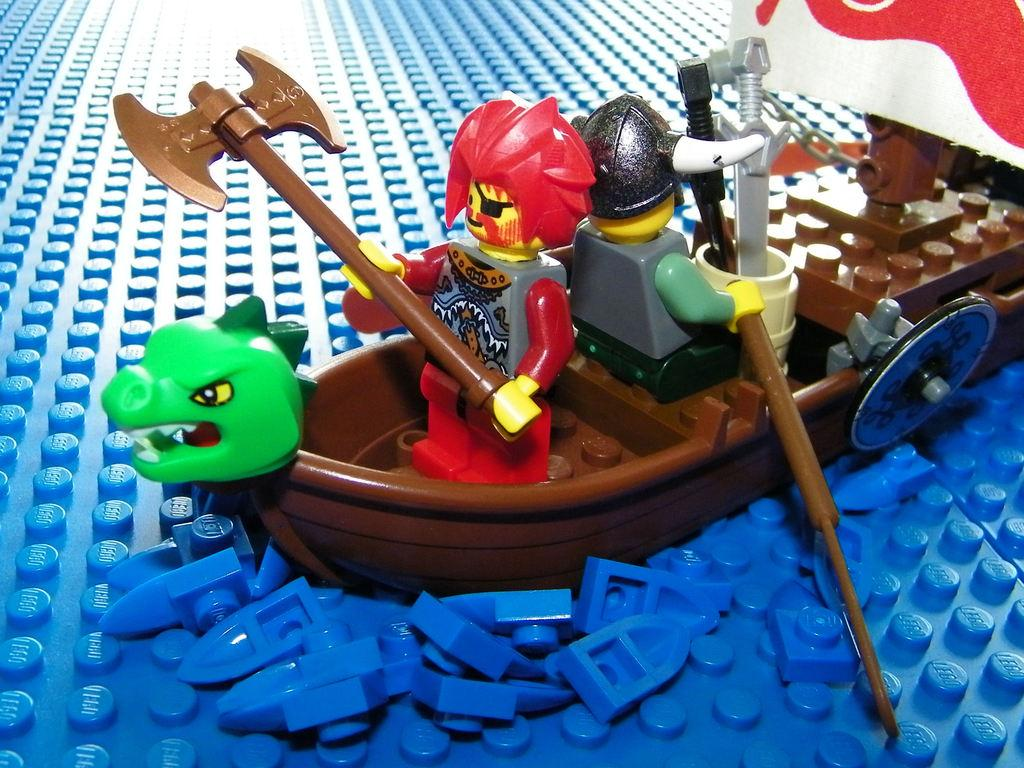What type of objects can be seen in the image? There are toys present in the image. What is the main subject of the image? There is a boat in the image. How many people are in the image? There are two men present in the image. Can you tell me how many boys are on the boat in the image? There is no boy present in the image; it only shows two men. What type of discovery can be seen in the image? There is no discovery present in the image; it features a boat and two men. 